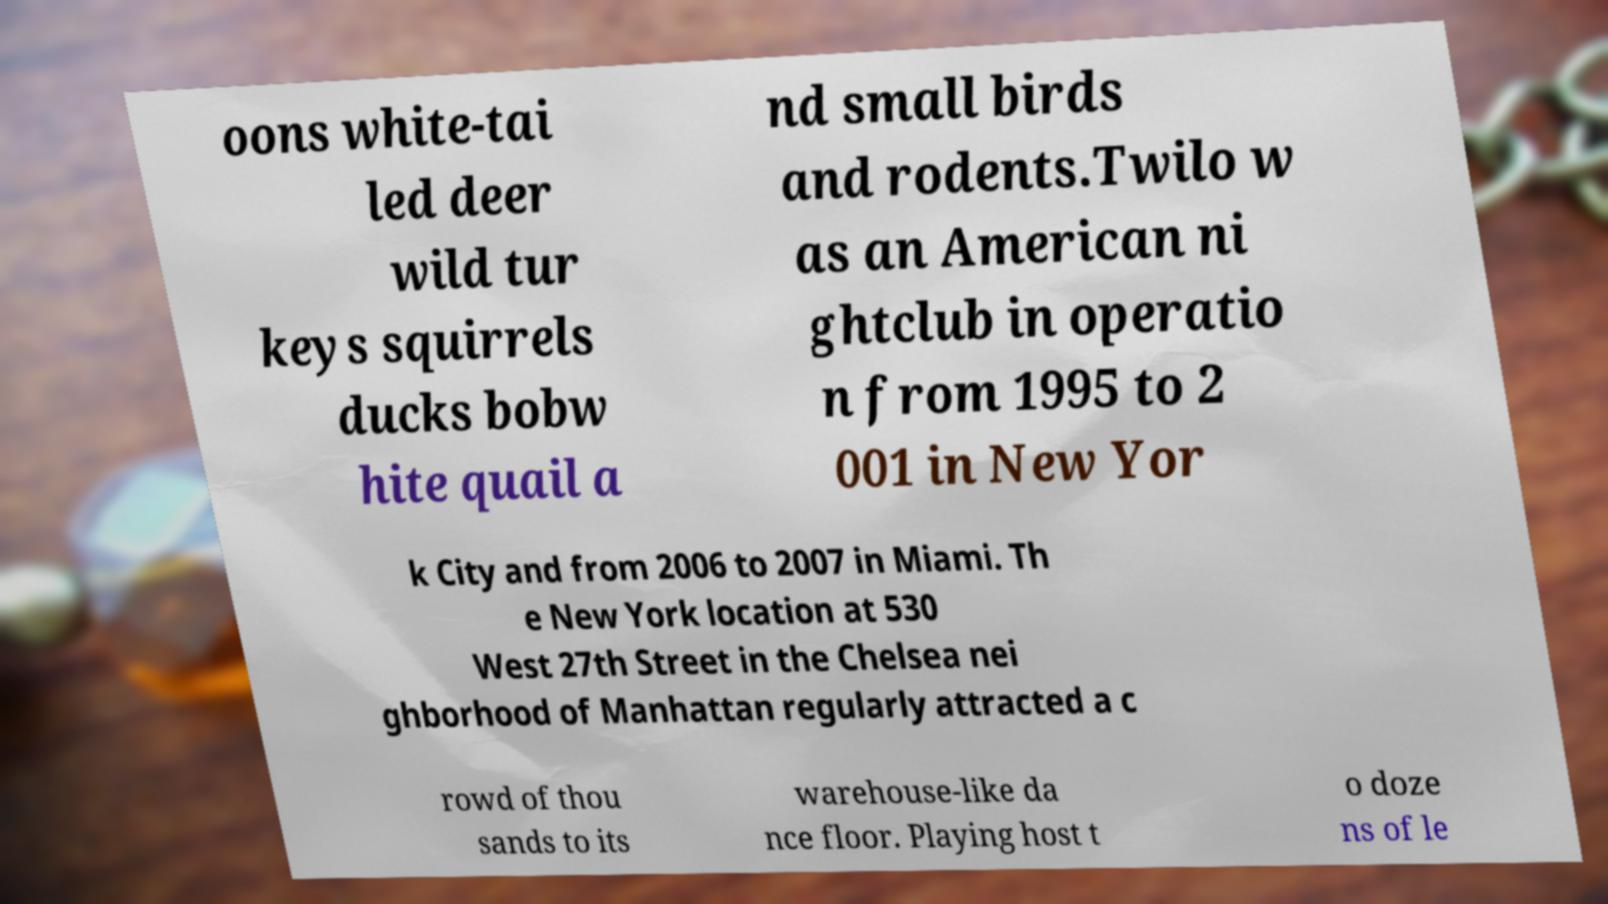What messages or text are displayed in this image? I need them in a readable, typed format. oons white-tai led deer wild tur keys squirrels ducks bobw hite quail a nd small birds and rodents.Twilo w as an American ni ghtclub in operatio n from 1995 to 2 001 in New Yor k City and from 2006 to 2007 in Miami. Th e New York location at 530 West 27th Street in the Chelsea nei ghborhood of Manhattan regularly attracted a c rowd of thou sands to its warehouse-like da nce floor. Playing host t o doze ns of le 